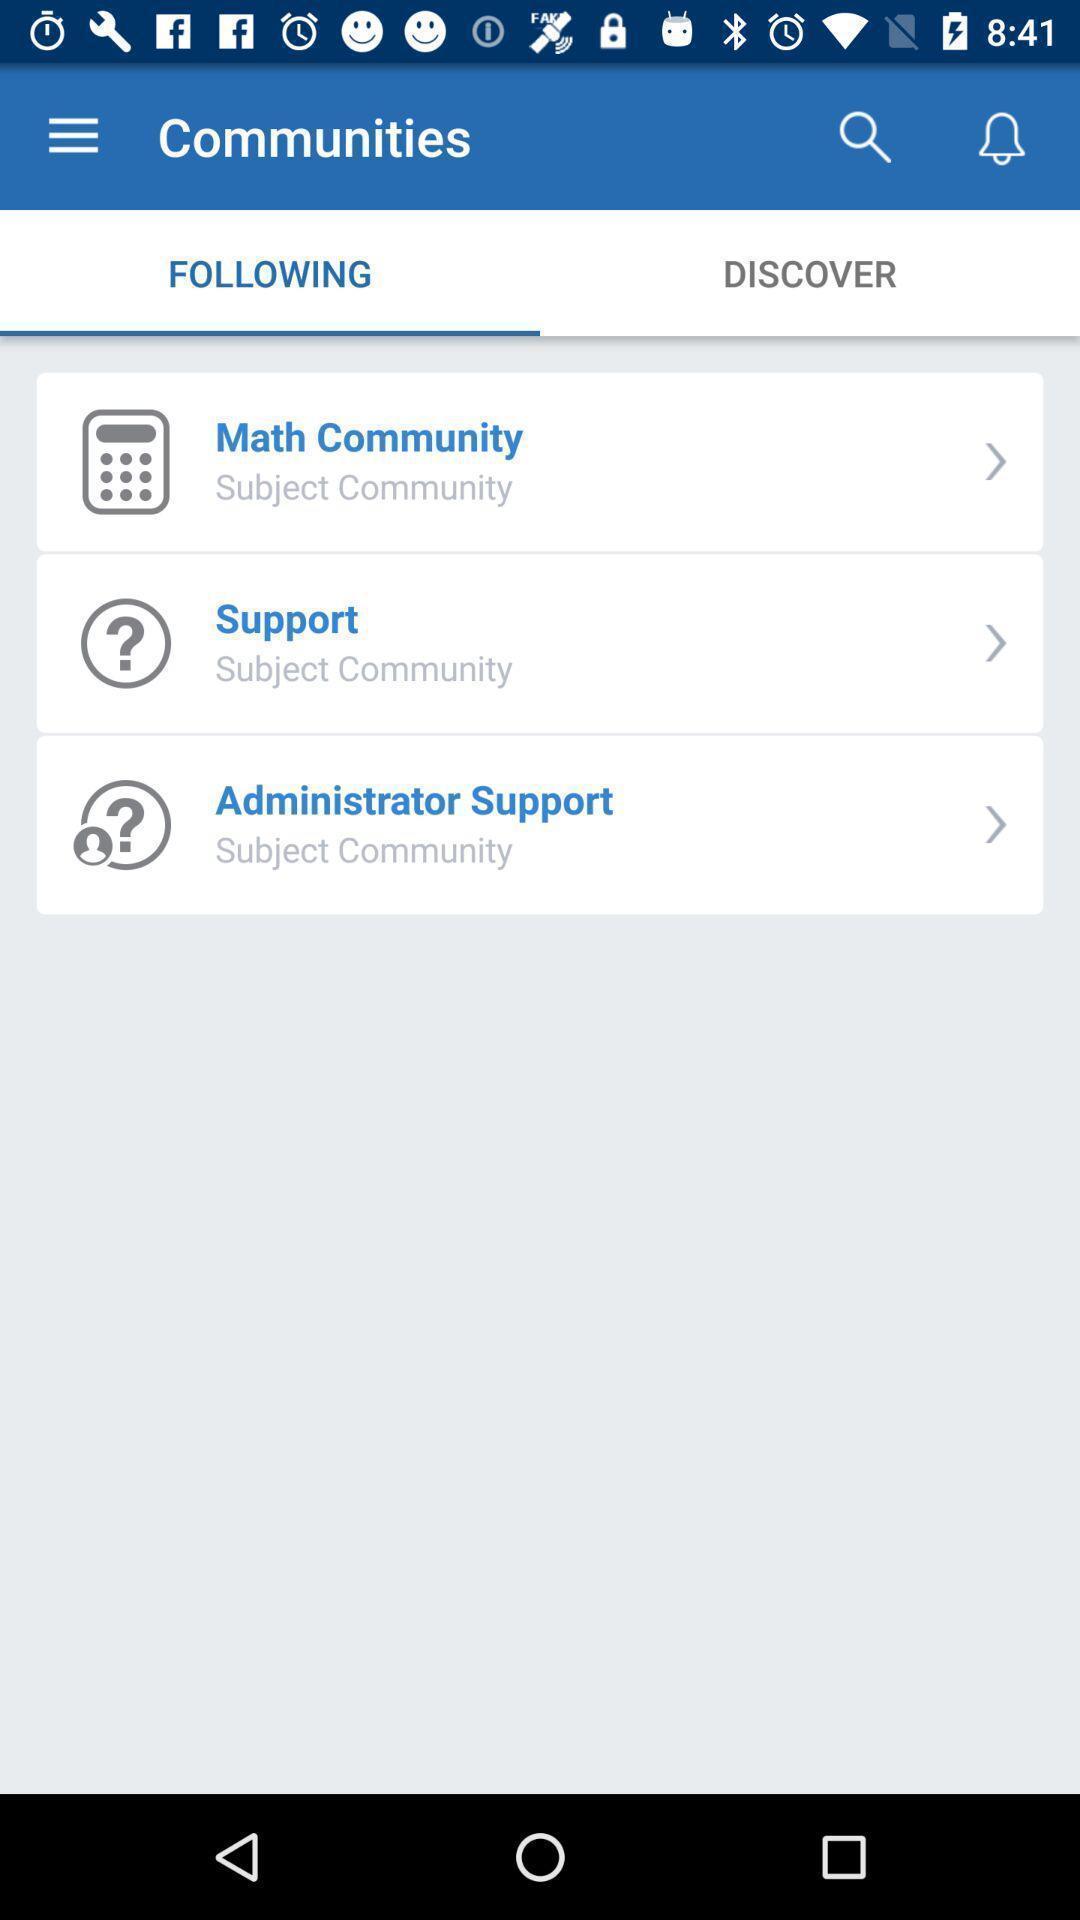What can you discern from this picture? Page showing communities on a learning app. 